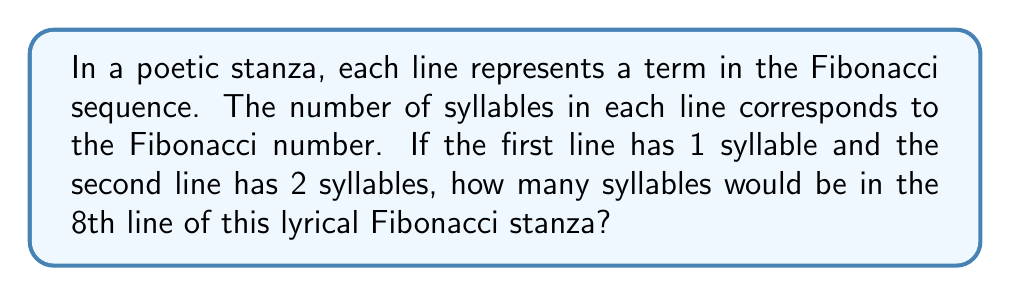Solve this math problem. To solve this problem, let's follow these steps:

1) Recall that the Fibonacci sequence is defined as:
   $F_n = F_{n-1} + F_{n-2}$, where $F_1 = 1$ and $F_2 = 1$

2) We're given that the first line has 1 syllable and the second line has 2 syllables. This corresponds to:
   $F_1 = 1$ (first line)
   $F_2 = 2$ (second line)

3) Let's calculate the subsequent terms:
   $F_3 = F_2 + F_1 = 2 + 1 = 3$
   $F_4 = F_3 + F_2 = 3 + 2 = 5$
   $F_5 = F_4 + F_3 = 5 + 3 = 8$
   $F_6 = F_5 + F_4 = 8 + 5 = 13$
   $F_7 = F_6 + F_5 = 13 + 8 = 21$
   $F_8 = F_7 + F_6 = 21 + 13 = 34$

4) Therefore, the 8th line of the stanza would have 34 syllables.

This poetic structure creates a rhythmic progression that mirrors the mathematical beauty of the Fibonacci sequence, blending the worlds of poetry and mathematics.
Answer: 34 